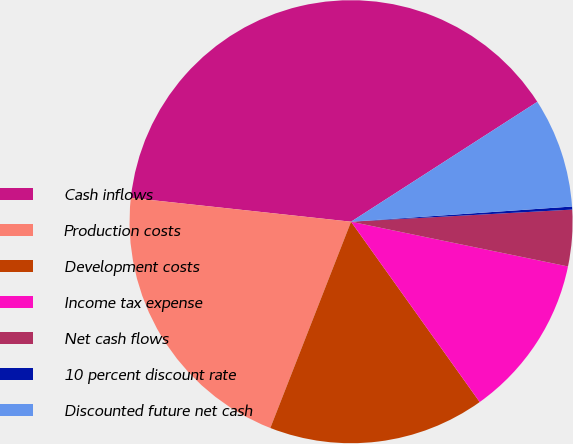<chart> <loc_0><loc_0><loc_500><loc_500><pie_chart><fcel>Cash inflows<fcel>Production costs<fcel>Development costs<fcel>Income tax expense<fcel>Net cash flows<fcel>10 percent discount rate<fcel>Discounted future net cash<nl><fcel>39.18%<fcel>20.78%<fcel>15.8%<fcel>11.9%<fcel>4.11%<fcel>0.22%<fcel>8.01%<nl></chart> 